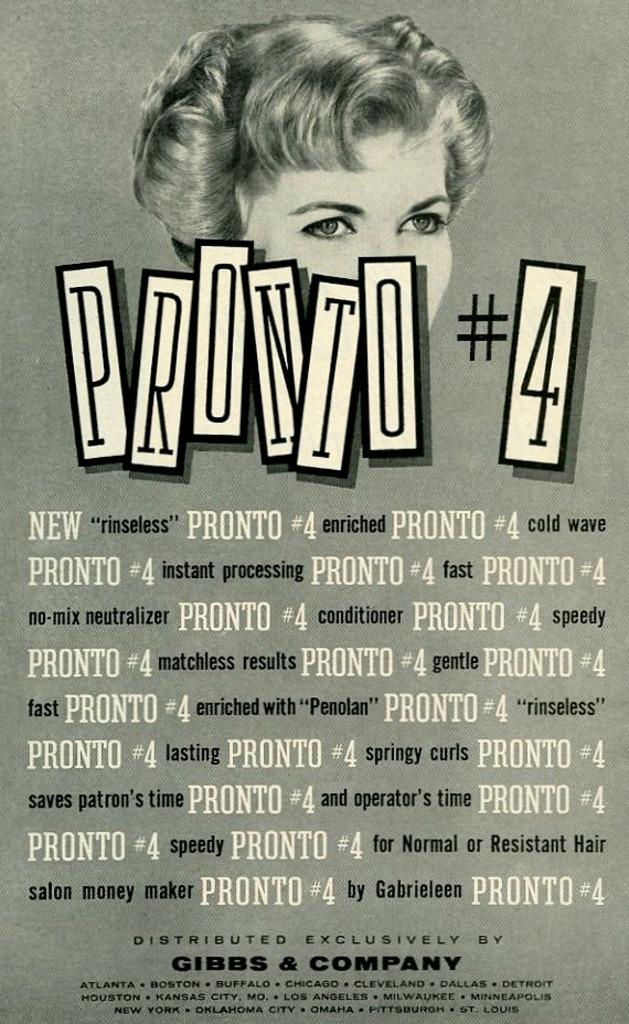What is #4?
Provide a succinct answer. Pronto. 